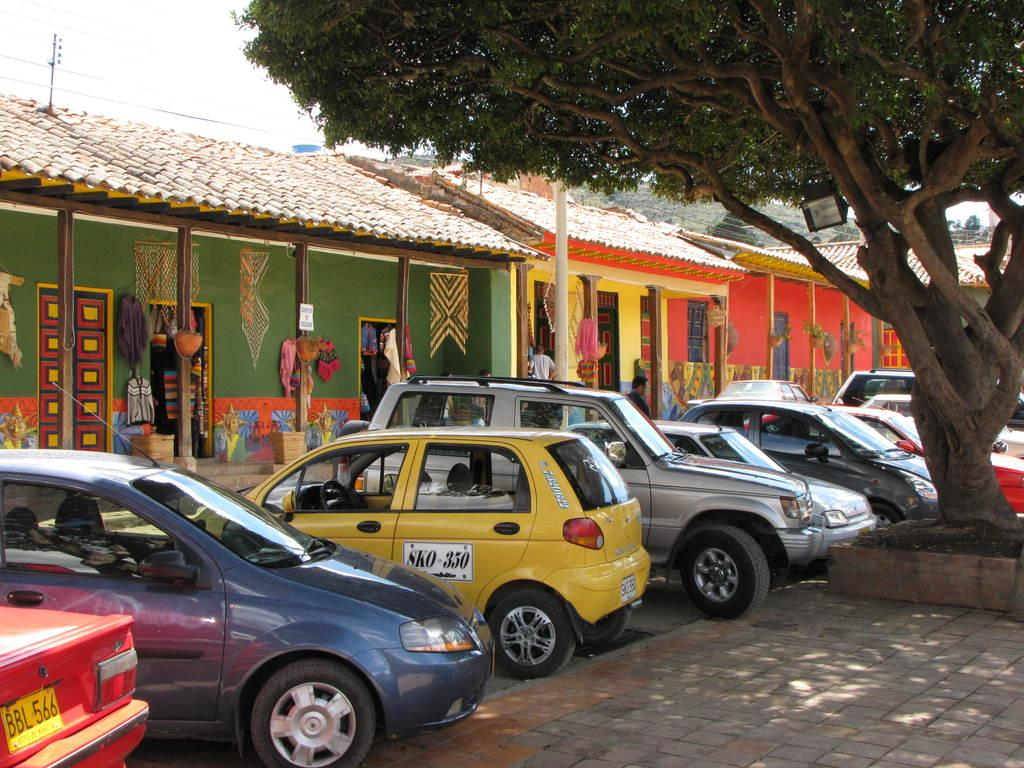<image>
Offer a succinct explanation of the picture presented. an sko 350 sign on the side of a car 